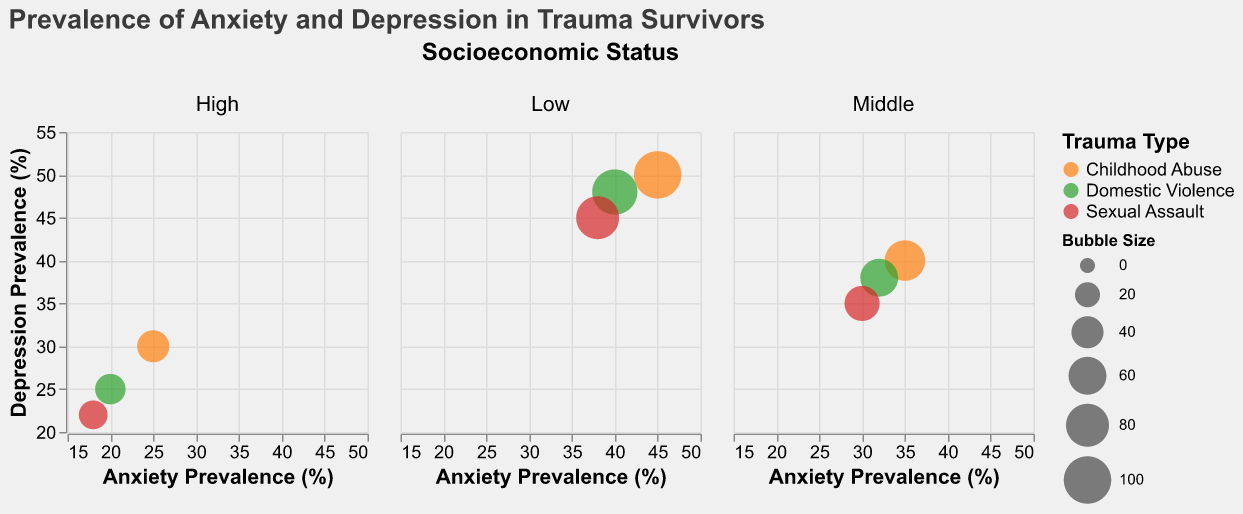What is the title of the figure? The title of the figure is typically found at the top and it provides an overall description of what the figure is about.
Answer: Prevalence of Anxiety and Depression in Trauma Survivors How many socioeconomic status groups are represented in the figure? The figure is divided into columns, each representing a different socioeconomic status group as indicated at the top of each column.
Answer: 3 Which trauma type in the Low socioeconomic status group has the highest depression prevalence? In the figure, we look at the Low SES column, and compare the depression prevalence percentages for different trauma types.
Answer: Childhood Abuse What is the anxiety prevalence for Domestic Violence in the High socioeconomic status group? Find the Domestic Violence bubble within the High SES column and note the value for anxiety prevalence on the x-axis.
Answer: 20% Comparing all trauma types in the Middle socioeconomic status group, which has the lowest bubble size? In the Middle SES column, compare the sizes of the circles for each trauma type.
Answer: Sexual Assault Which socioeconomic status group has generally the lowest prevalence of both anxiety and depression across all trauma types? By comparing the positions of the circles across the columns, the group with lower values on both axes for multiple trauma types can be identified.
Answer: High What is the difference in depression prevalence between Childhood Abuse and Sexual Assault in the Low socioeconomic status group? Subtract the depression prevalence value of Sexual Assault from that of Childhood Abuse in the Low SES group.
Answer: 50 - 45 = 5% Is the size of the bubble for Childhood Abuse in the Middle socioeconomic status larger than the bubble for Domestic Violence in the High socioeconomic status? Compare the bubble sizes listed for both categories in their respective SES columns.
Answer: Yes Which trauma type in the Middle socioeconomic status has a higher depression prevalence: Childhood Abuse or Domestic Violence? Compare the depression prevalence values on the y-axis for Childhood Abuse and Domestic Violence in the Middle SES group.
Answer: Childhood Abuse What is the average anxiety prevalence for all trauma types in the High socioeconomic status group? Add the anxiety prevalence values for all trauma types in the High SES group and divide by the number of trauma types (3).
Answer: (25 + 20 + 18) / 3 = 21% 